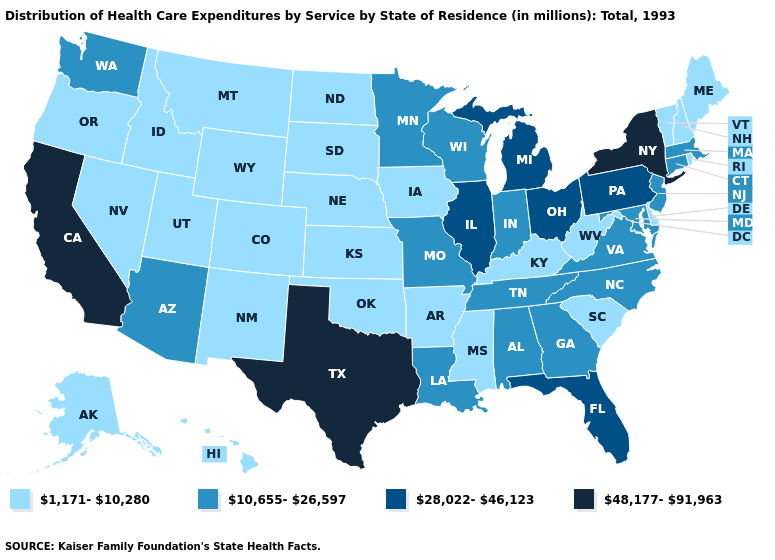Name the states that have a value in the range 10,655-26,597?
Short answer required. Alabama, Arizona, Connecticut, Georgia, Indiana, Louisiana, Maryland, Massachusetts, Minnesota, Missouri, New Jersey, North Carolina, Tennessee, Virginia, Washington, Wisconsin. Among the states that border New Jersey , which have the highest value?
Be succinct. New York. What is the value of Washington?
Short answer required. 10,655-26,597. What is the lowest value in the South?
Be succinct. 1,171-10,280. Which states have the highest value in the USA?
Write a very short answer. California, New York, Texas. What is the highest value in the MidWest ?
Give a very brief answer. 28,022-46,123. Among the states that border New Mexico , does Texas have the highest value?
Give a very brief answer. Yes. Name the states that have a value in the range 48,177-91,963?
Short answer required. California, New York, Texas. What is the value of Wisconsin?
Concise answer only. 10,655-26,597. Among the states that border New Jersey , which have the lowest value?
Quick response, please. Delaware. Is the legend a continuous bar?
Answer briefly. No. Does Nevada have the lowest value in the West?
Concise answer only. Yes. Name the states that have a value in the range 48,177-91,963?
Answer briefly. California, New York, Texas. What is the value of Nebraska?
Be succinct. 1,171-10,280. Name the states that have a value in the range 48,177-91,963?
Answer briefly. California, New York, Texas. 